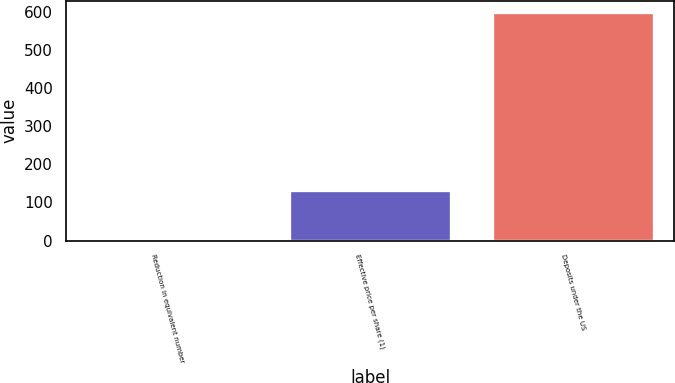<chart> <loc_0><loc_0><loc_500><loc_500><bar_chart><fcel>Reduction in equivalent number<fcel>Effective price per share (1)<fcel>Deposits under the US<nl><fcel>5<fcel>132.32<fcel>600<nl></chart> 